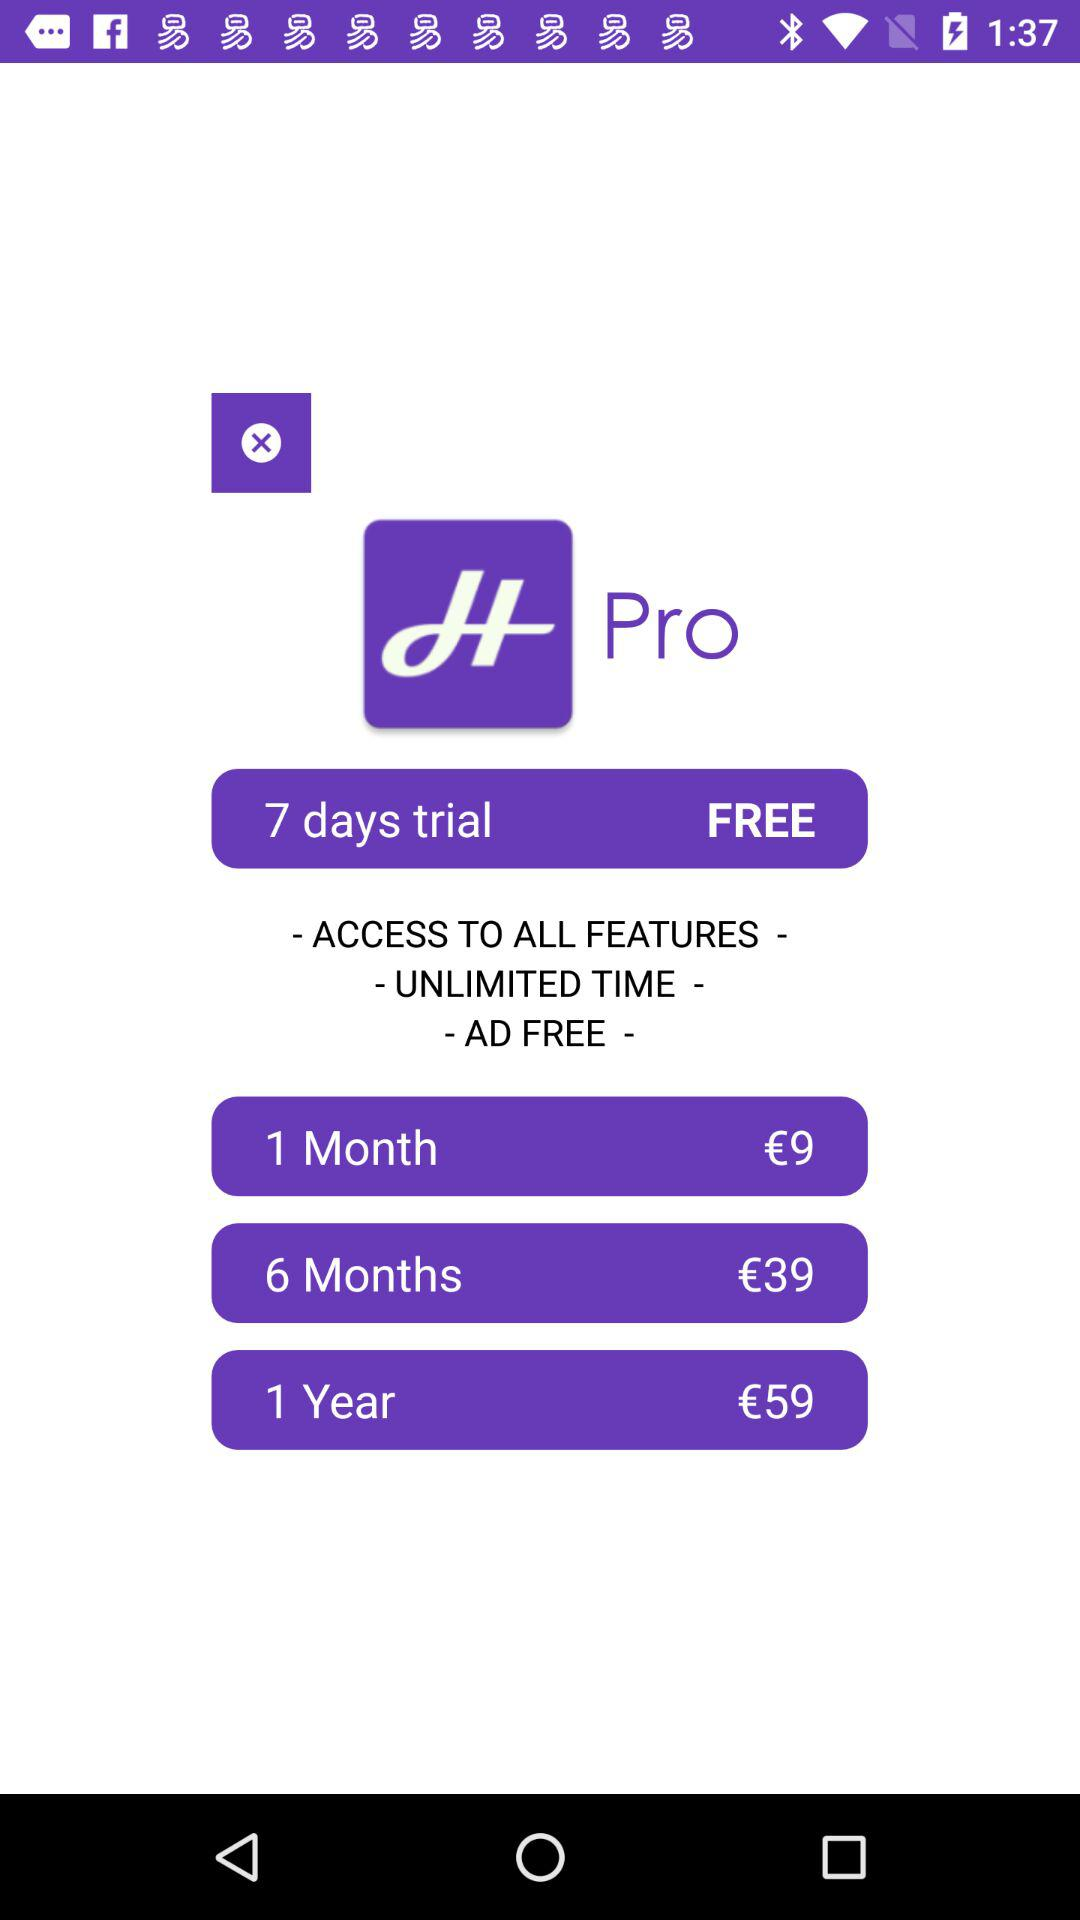How much more does a year of Pro cost than 6 months?
Answer the question using a single word or phrase. €20 